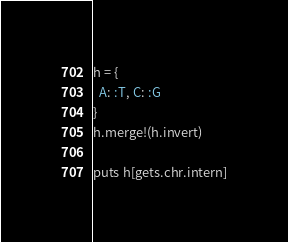<code> <loc_0><loc_0><loc_500><loc_500><_Ruby_>h = {
  A: :T, C: :G
}
h.merge!(h.invert)

puts h[gets.chr.intern]
</code> 